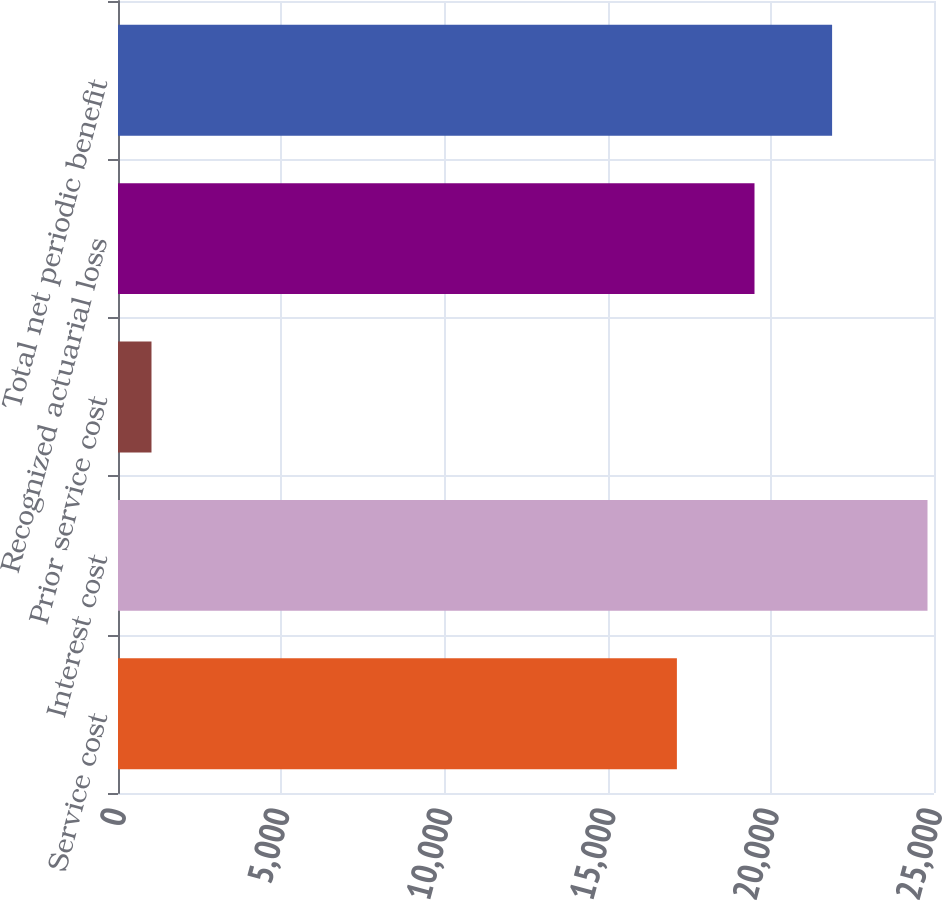Convert chart. <chart><loc_0><loc_0><loc_500><loc_500><bar_chart><fcel>Service cost<fcel>Interest cost<fcel>Prior service cost<fcel>Recognized actuarial loss<fcel>Total net periodic benefit<nl><fcel>17123<fcel>24801<fcel>1026<fcel>19500.5<fcel>21878<nl></chart> 